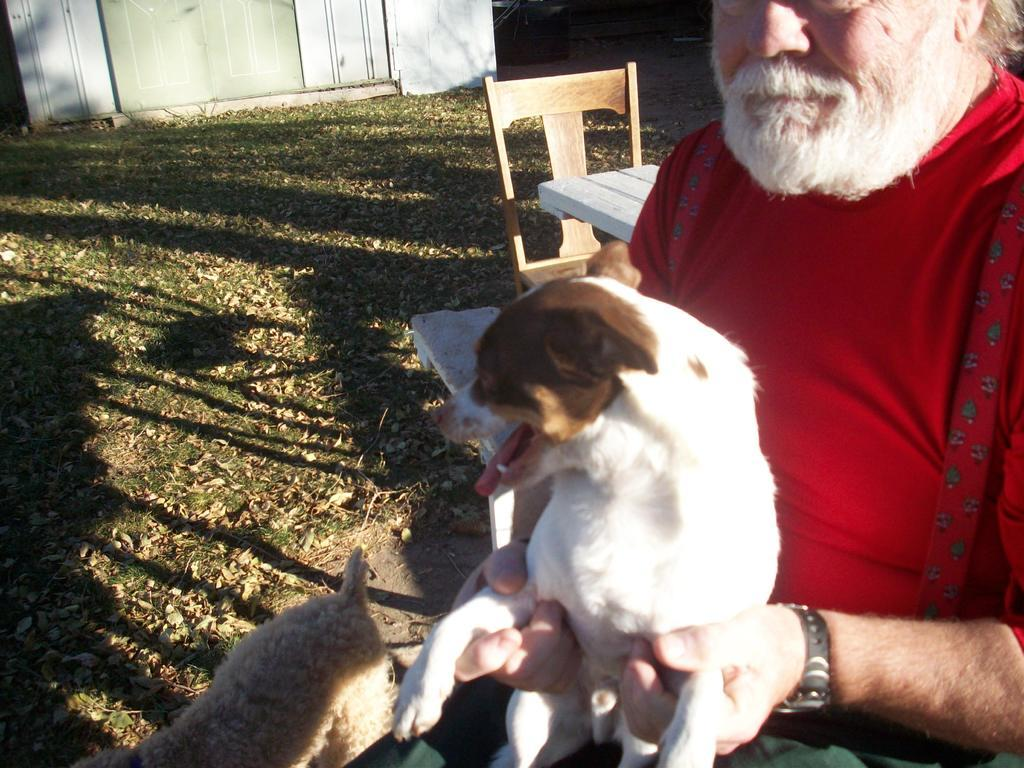Who is in the image? There is an old man in the image. What is the old man holding? The old man is holding a dog. What piece of furniture is in the image? There is a chair in the image. What is on the floor in the image? Dry leaves are present on the floor. What type of vegetation is visible on the floor? Grass is visible on the floor. What color crayon is the old man using to give advice to the dogs in the image? There is no crayon or advice-giving in the image; the old man is simply holding a dog. 